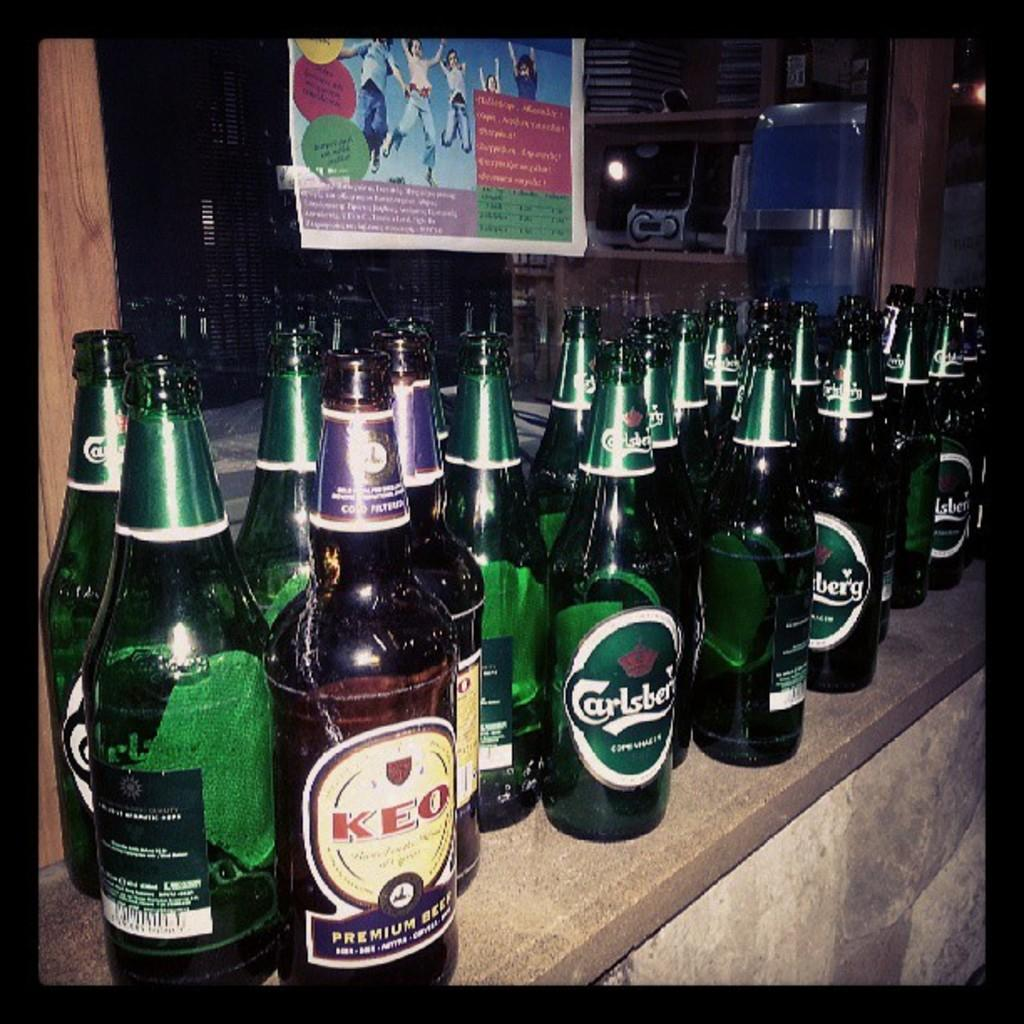What objects can be seen on the counter in the image? There are many bottles on the counter in the image. What can be seen in the background of the image? There is a banner and a glass wall in the background. How many pins are being used by the governor to play volleyball in the image? There is no governor, volleyball, or pins present in the image. 